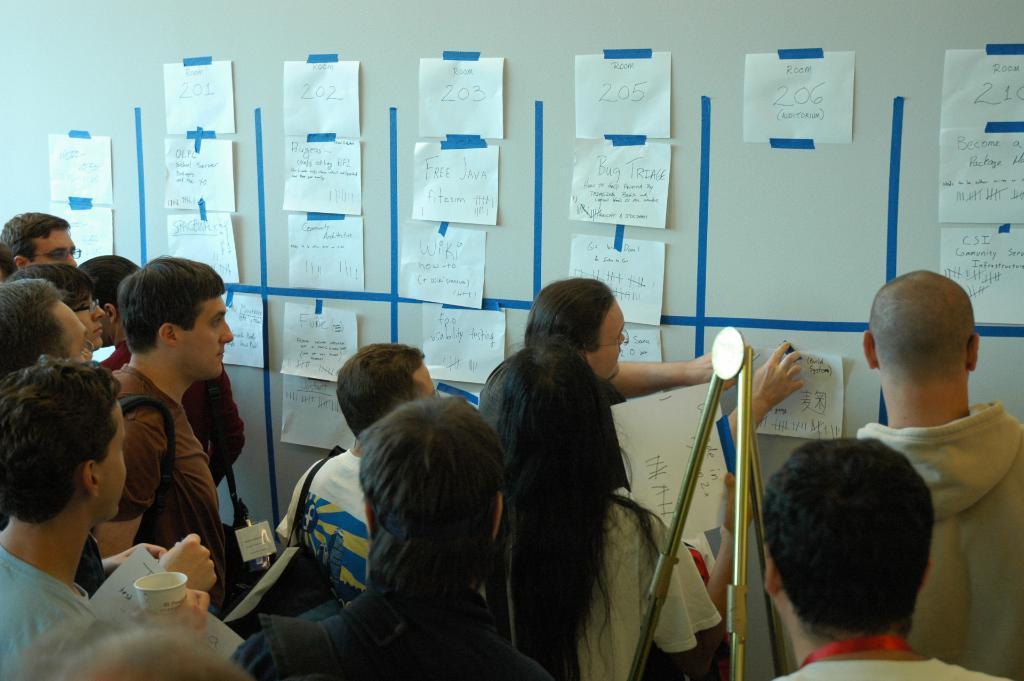What are the people in the image doing? The people in the image are standing and holding papers in their hands. What can be seen on the walls in the background? There are papers pasted on the walls in the background. What equipment is visible in the background? There is a tripod visible in the background. What type of stick can be seen rolling on the floor in the image? There is no stick or rolling object present in the image. 